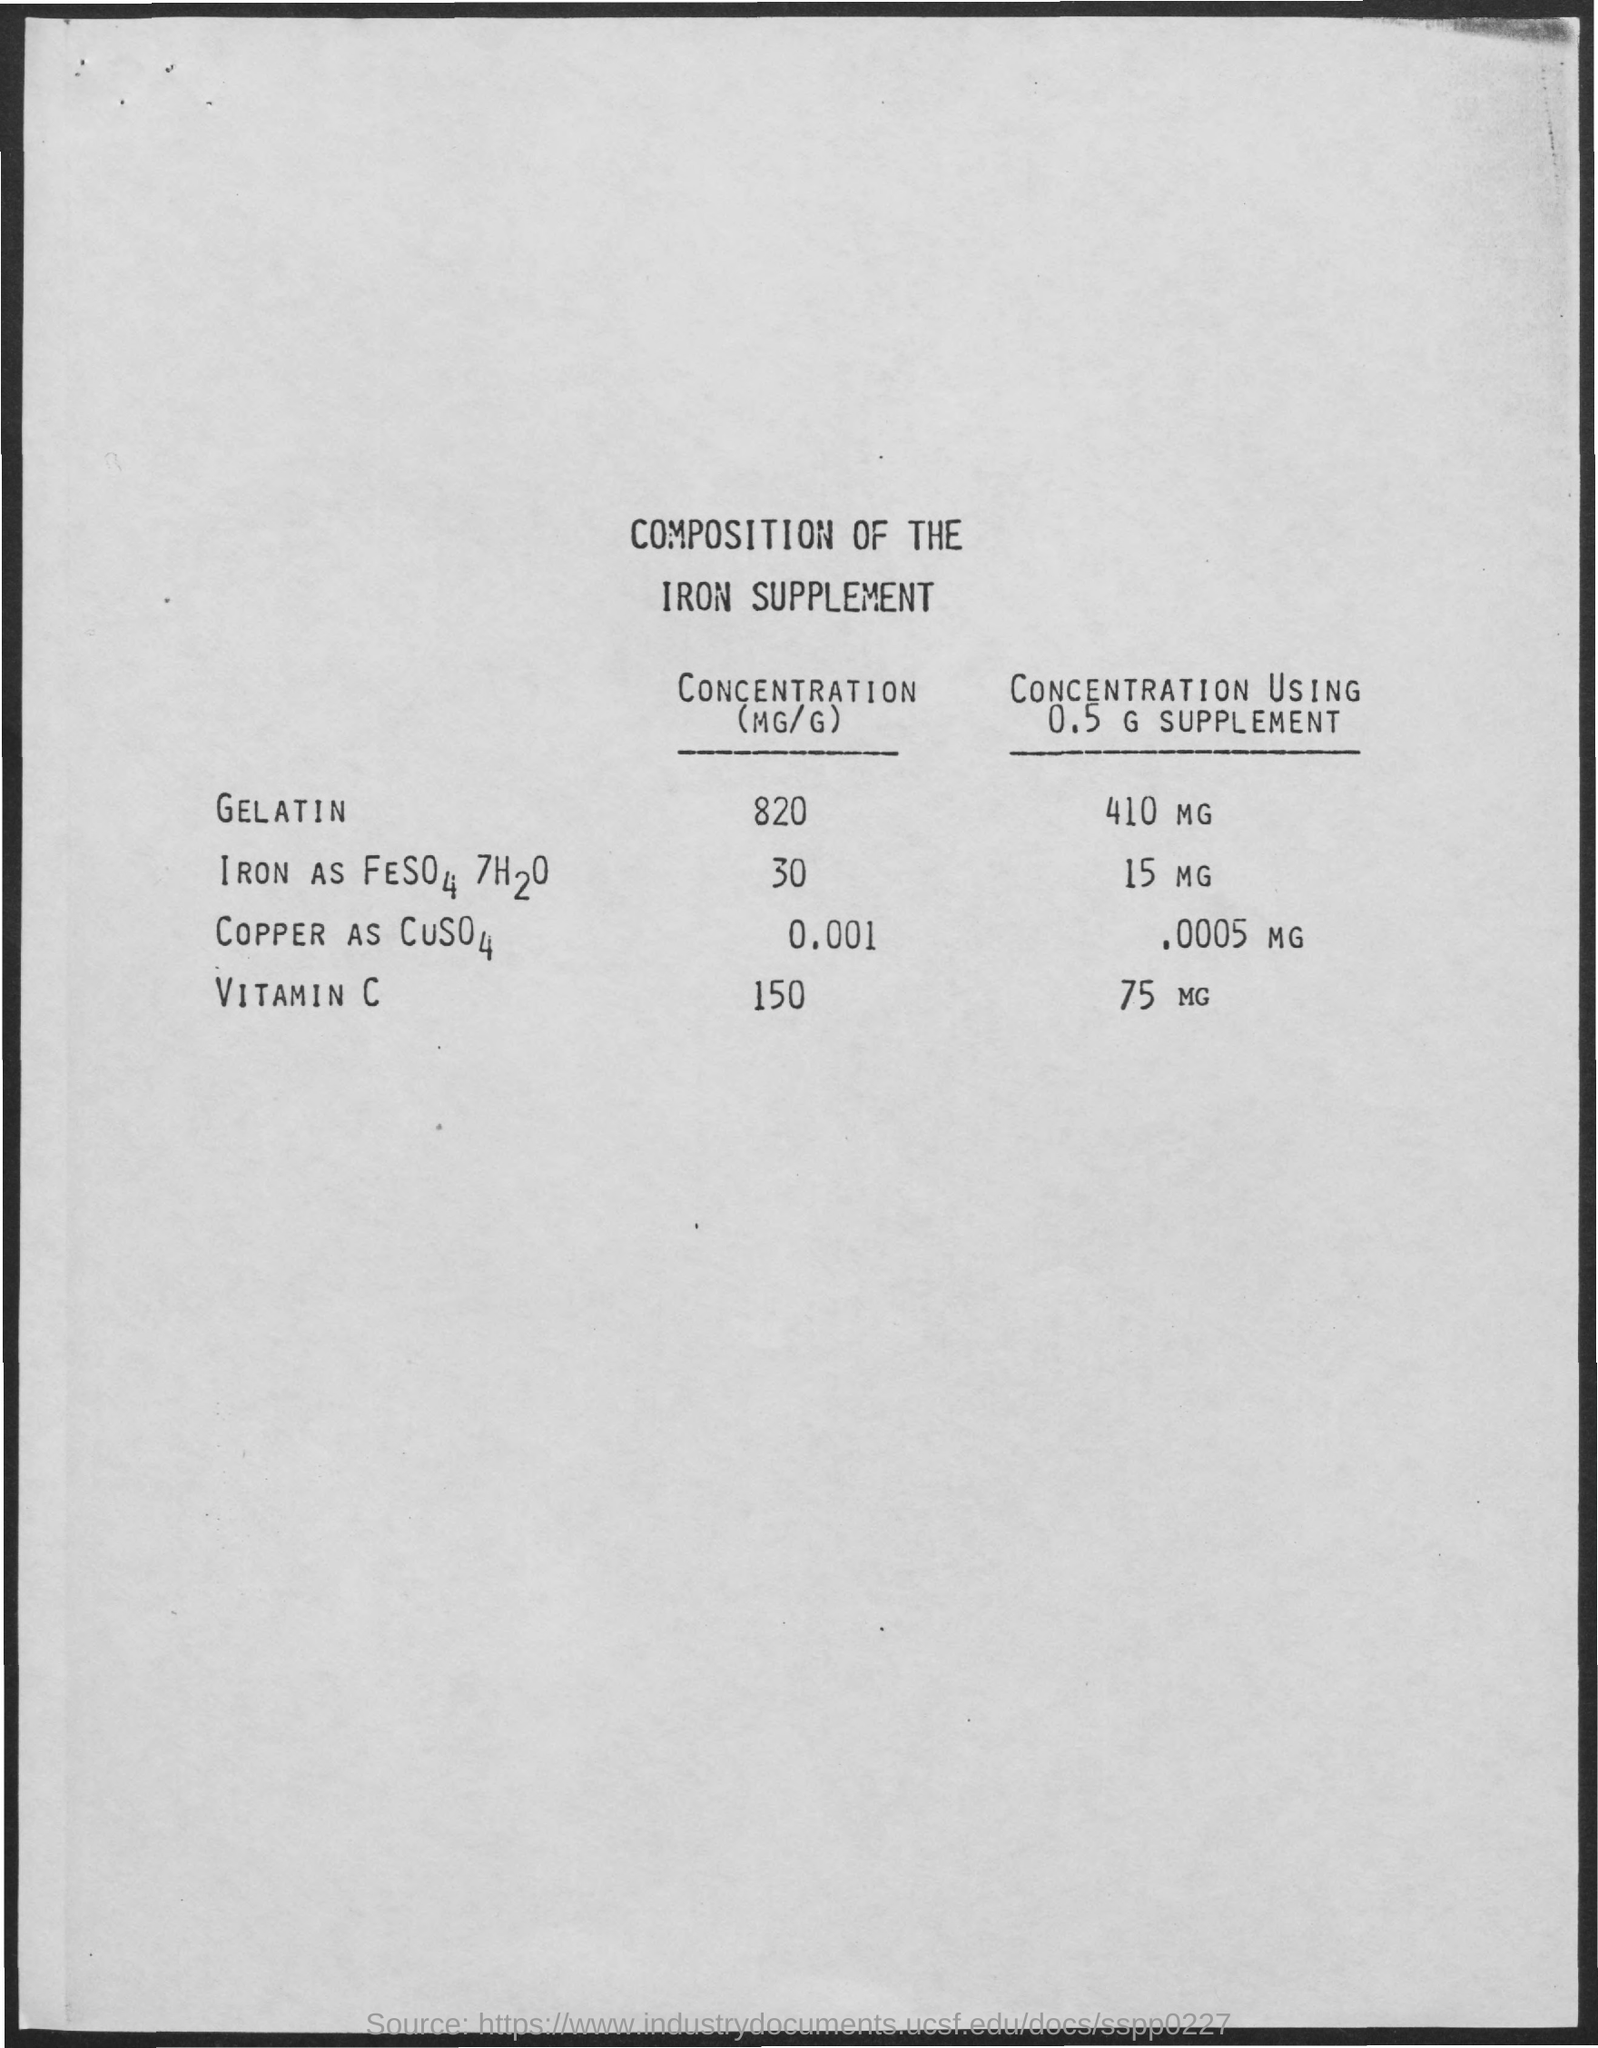Identify some key points in this picture. The gelatin supplement is 0.5 grams and contains 410 milligrams, leading to a concentration of [insert unit of concentration]. The concentration value of gelatin is 820. The concentration of vitamin C is 150... 